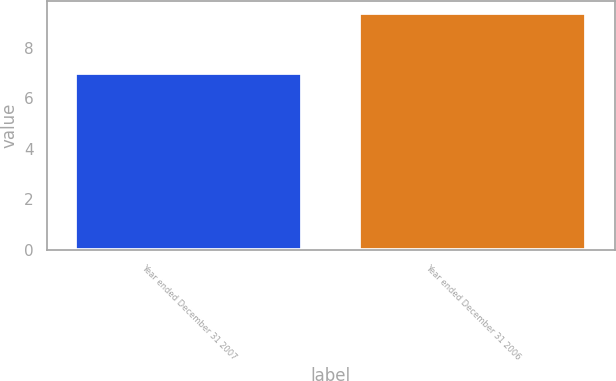<chart> <loc_0><loc_0><loc_500><loc_500><bar_chart><fcel>Year ended December 31 2007<fcel>Year ended December 31 2006<nl><fcel>7<fcel>9.4<nl></chart> 